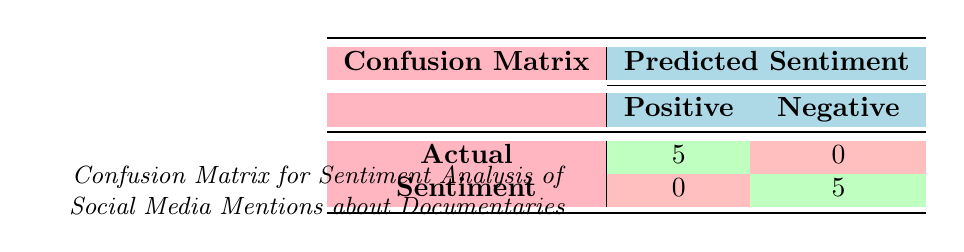What is the total number of actual positive sentiments in the confusion matrix? The confusion matrix shows that there are 5 instances where the actual sentiment is positive, as indicated in the cell corresponding to actual positive and predicted positive.
Answer: 5 What is the total number of actual negative sentiments in the confusion matrix? The matrix indicates that there are 5 instances where the actual sentiment is negative, represented in the cell for actual negative and predicted negative.
Answer: 5 Is there any instance of an actual positive sentiment predicted as negative? In the confusion matrix, the cell for actual positive sentiment and predicted negative shows 0, meaning there are no instances where a positive sentiment was incorrectly predicted as negative.
Answer: No What percentage of actual sentiments were predicted correctly in the confusion matrix? All 10 instances (5 actual positives + 5 actual negatives) were predicted correctly, so the percentage is (10 / 10) * 100 = 100%.
Answer: 100% How many instances had negative sentiments, and how were they predicted? There are 5 instances with negative sentiments, and all were predicted as negative, seen in the actual negative row where all values are correct.
Answer: 5 instances, all predicted as negative What is the difference between the number of actual positive sentiments and negative sentiments? The matrix shows 5 actual positives and 5 actual negatives, so the difference is 5 - 5 = 0.
Answer: 0 What is the true positive rate from the confusion matrix? The true positive rate is calculated as true positives divided by the total number of actual positives. Here, there are 5 true positives and 5 actual positives: 5 / 5 = 1 (or 100%).
Answer: 100% Are there any false positives in the confusion matrix? A false positive occurs when an actual negative sentiment is predicted as positive. The matrix shows 0 in the cell for actual negative and predicted positive, indicating there are no false positives.
Answer: No How many total mentions were analyzed to generate this confusion matrix? The confusion matrix consists of 10 data points (5 actual positive + 5 actual negative), indicating the total number of mentions analyzed is 10.
Answer: 10 